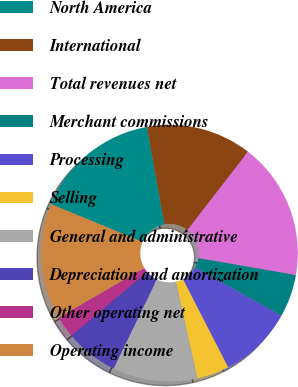Convert chart. <chart><loc_0><loc_0><loc_500><loc_500><pie_chart><fcel>North America<fcel>International<fcel>Total revenues net<fcel>Merchant commissions<fcel>Processing<fcel>Selling<fcel>General and administrative<fcel>Depreciation and amortization<fcel>Other operating net<fcel>Operating income<nl><fcel>15.94%<fcel>13.3%<fcel>17.26%<fcel>5.38%<fcel>9.34%<fcel>4.06%<fcel>10.66%<fcel>6.7%<fcel>2.74%<fcel>14.62%<nl></chart> 